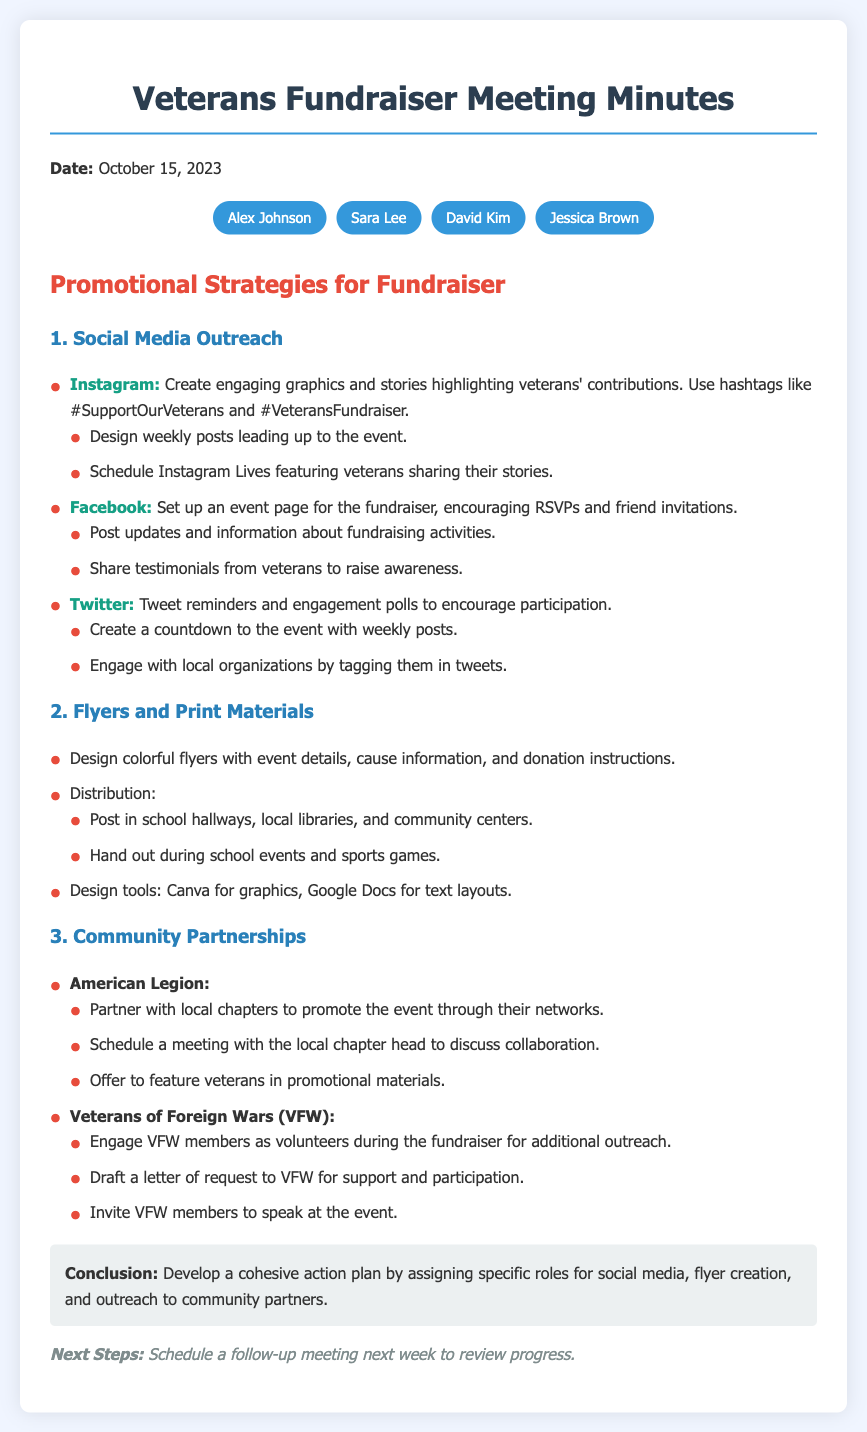what date was the meeting held? The date of the meeting is stated at the beginning of the document.
Answer: October 15, 2023 who is responsible for social media outreach? The document mentions social media outreach as a task without assigning specific individuals.
Answer: Not specified what platforms are mentioned for social media outreach? The document lists specific platforms used for outreach within the promotional strategies section.
Answer: Instagram, Facebook, Twitter how many attendees were present at the meeting? The number of attendees can be counted from the list provided in the attendees section.
Answer: 4 which design tools are mentioned for creating flyers? The tools used for designing flyers are specified in the flyer section of the document.
Answer: Canva, Google Docs what is the main purpose of the fundraiser? The main purpose is hinted at within the context of promotional strategies discussed.
Answer: Support veterans' organizations what organizations are partnered with for community outreach? The document lists specific organizations for potential partnerships under the community partnerships section.
Answer: American Legion, Veterans of Foreign Wars (VFW) what type of materials are used for promoting the fundraiser? The document describes the types of materials employed in the promotional strategy.
Answer: Flyers and print materials how often should social media posts be designed leading up to the event? The document suggests a frequency for posts in the social media outreach section.
Answer: Weekly 